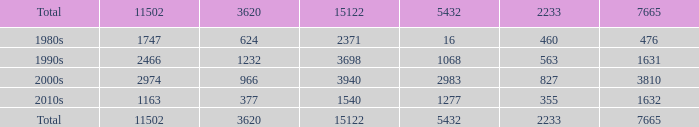What is the average 3620 value that has a 5432 of 1277 and a 15122 less than 1540? None. 